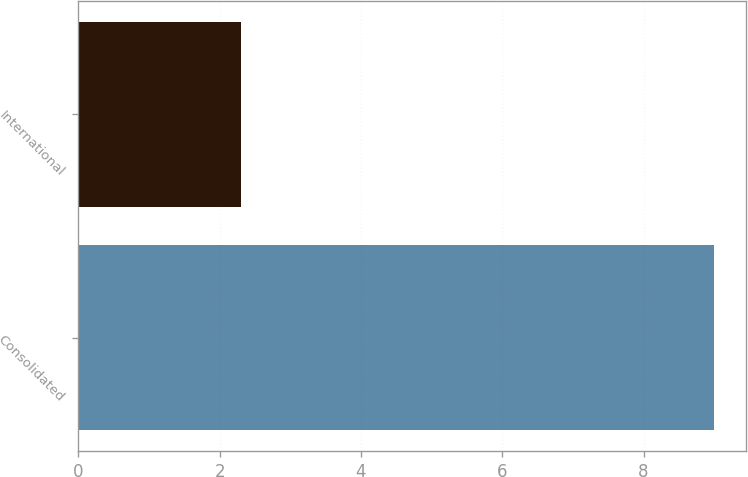Convert chart. <chart><loc_0><loc_0><loc_500><loc_500><bar_chart><fcel>Consolidated<fcel>International<nl><fcel>9<fcel>2.3<nl></chart> 